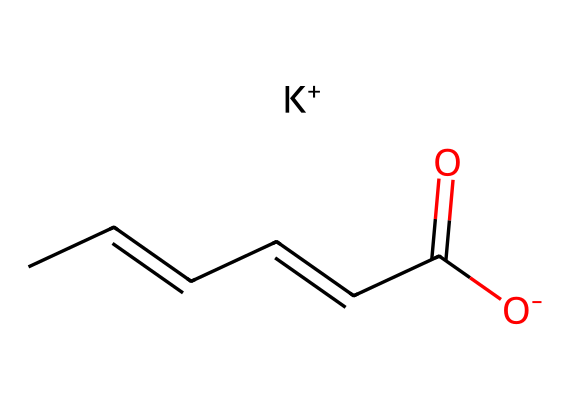How many carbon atoms are present in potassium sorbate? The given SMILES representation shows a chain of carbon atoms. Counting the 'C' symbols in the structure, there are six carbon atoms in total.
Answer: six What is the primary functional group in potassium sorbate? Analyzing the SMILES reveals the presence of a carboxylate group (C(=O)[O-]) which indicates the presence of the carboxylic acid functional group, even though the acid itself is deprotonated here.
Answer: carboxylate What is the valence of potassium in this chemical? Potassium is represented as K+ in the SMILES, which indicates it has a +1 charge, consistent with its group in the periodic table where it typically has one valence electron.
Answer: +1 Which part of the molecule contributes to its antimicrobial properties? The carboxylate group (C(=O)[O-]) is critical as it is known to interfere with the metabolism of microbes, which is how potassium sorbate exerts its preservative effect.
Answer: carboxylate group What is the total number of hydrogen atoms in potassium sorbate? From the structure, initially, the alkene and carboxylic features indicate there are 8 hydrogen atoms connected to the carbons, derived from the overall molecular formulation when considering hydrogen saturation rules.
Answer: eight 